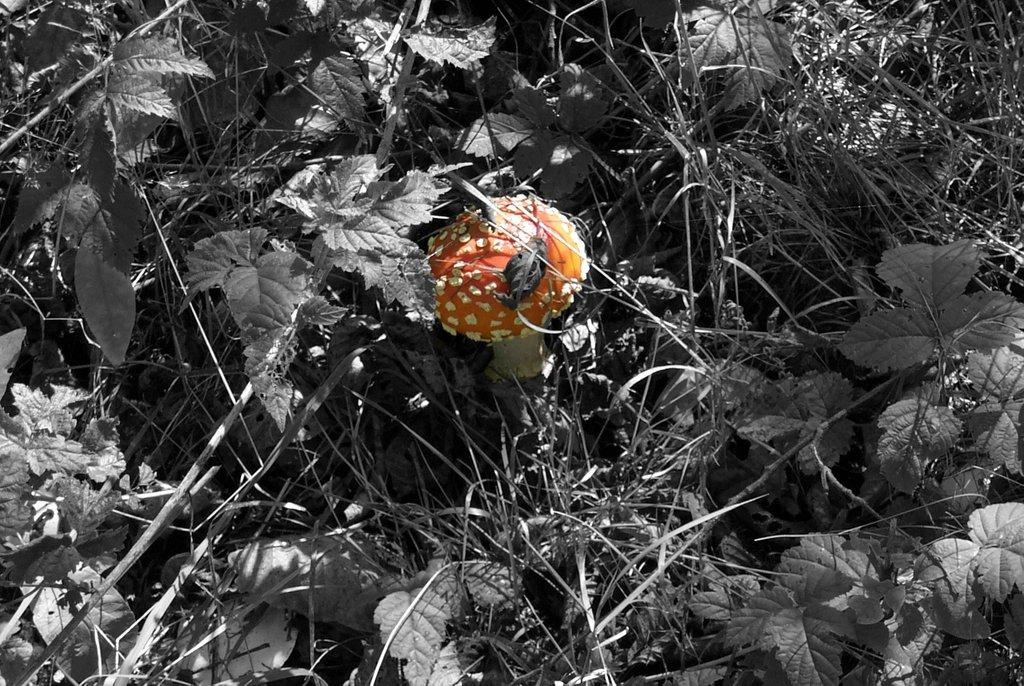What is the main subject in the center of the image? There is an object in the center of the image. Can you describe the color of the object? The object is orange in color. What can be seen in the front of the image? There are leaves in the front of the image. What language is being spoken by the volcano in the image? There is no volcano present in the image, and therefore no language being spoken by it. 